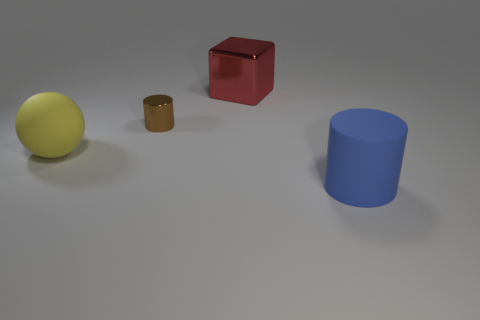There is a rubber thing to the right of the metal cylinder; is its shape the same as the shiny thing left of the large red metal thing?
Offer a very short reply. Yes. How many other objects are the same size as the red shiny block?
Make the answer very short. 2. Is the number of big blue matte objects that are on the left side of the big yellow matte sphere less than the number of big yellow balls that are left of the big metal object?
Offer a terse response. Yes. What color is the big thing that is both in front of the big shiny object and behind the big rubber cylinder?
Give a very brief answer. Yellow. There is a blue matte cylinder; is its size the same as the cylinder behind the sphere?
Your answer should be compact. No. What is the shape of the rubber thing left of the blue thing?
Provide a short and direct response. Sphere. Are there more big metallic cubes that are on the right side of the large yellow object than small red matte balls?
Your response must be concise. Yes. How many objects are behind the rubber object left of the matte thing that is in front of the big rubber sphere?
Offer a very short reply. 2. Is the size of the rubber thing to the left of the large rubber cylinder the same as the cylinder that is behind the blue object?
Your answer should be compact. No. What material is the big sphere that is left of the rubber cylinder on the right side of the brown metallic cylinder?
Your answer should be very brief. Rubber. 